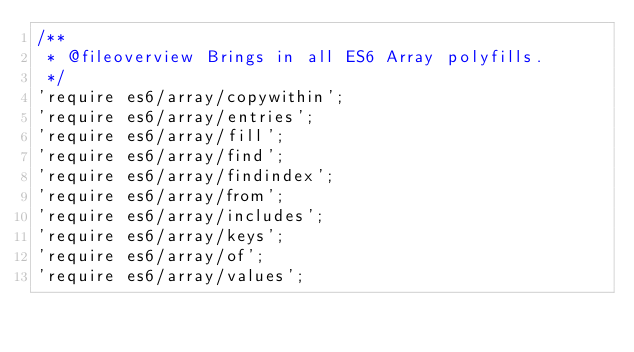Convert code to text. <code><loc_0><loc_0><loc_500><loc_500><_JavaScript_>/**
 * @fileoverview Brings in all ES6 Array polyfills.
 */
'require es6/array/copywithin';
'require es6/array/entries';
'require es6/array/fill';
'require es6/array/find';
'require es6/array/findindex';
'require es6/array/from';
'require es6/array/includes';
'require es6/array/keys';
'require es6/array/of';
'require es6/array/values';
</code> 